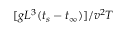<formula> <loc_0><loc_0><loc_500><loc_500>[ g L ^ { 3 } ( t _ { s } - t _ { \infty } ) ] / v ^ { 2 } T</formula> 